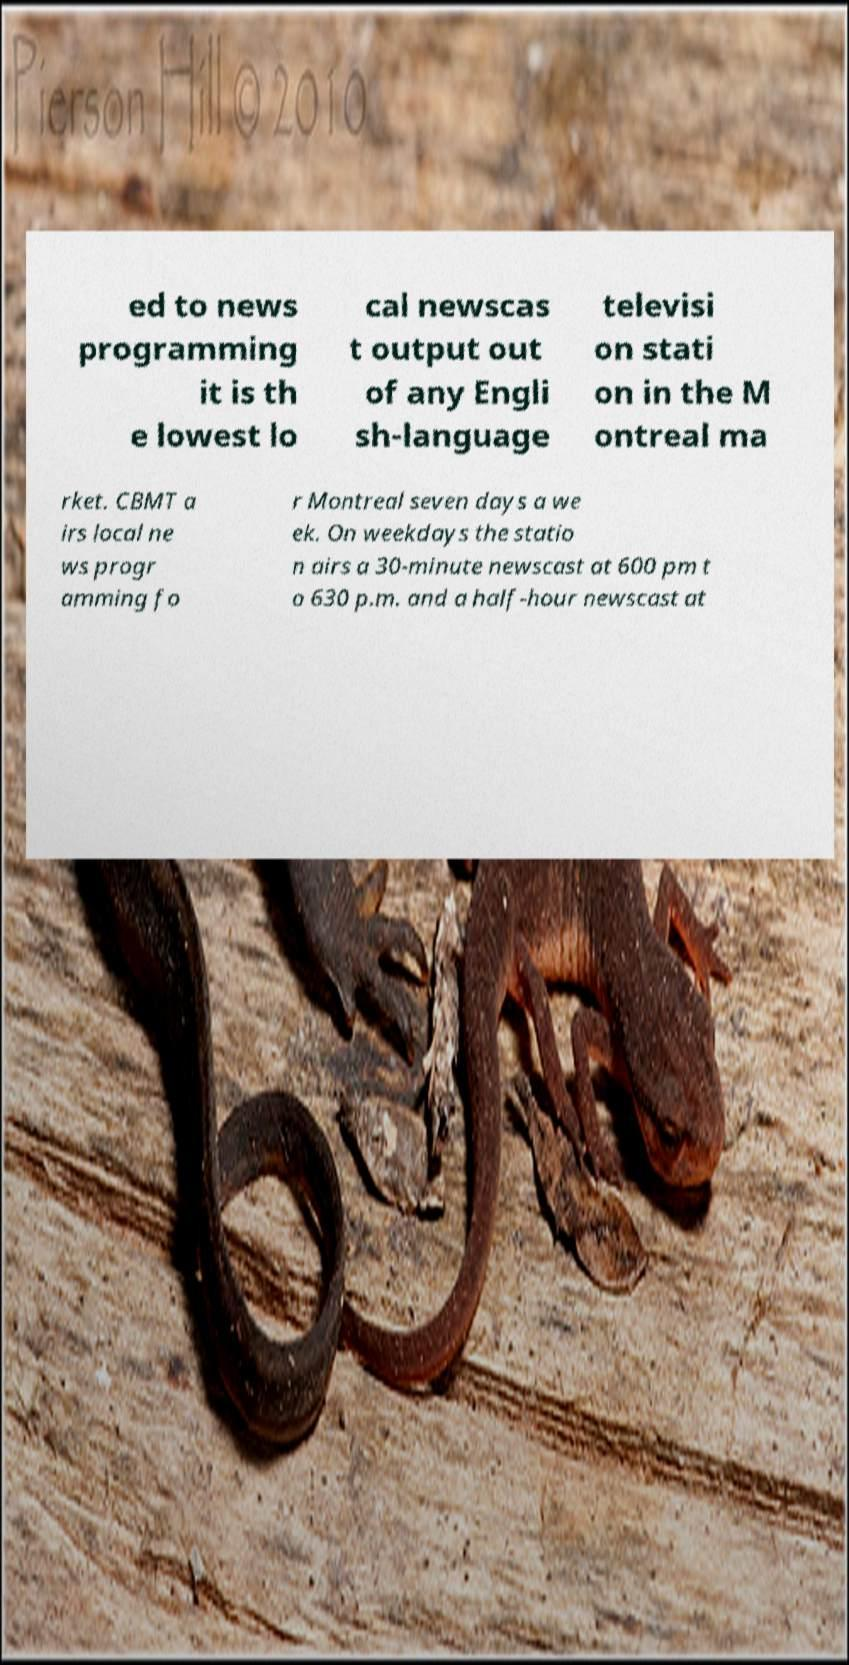Could you assist in decoding the text presented in this image and type it out clearly? ed to news programming it is th e lowest lo cal newscas t output out of any Engli sh-language televisi on stati on in the M ontreal ma rket. CBMT a irs local ne ws progr amming fo r Montreal seven days a we ek. On weekdays the statio n airs a 30-minute newscast at 600 pm t o 630 p.m. and a half-hour newscast at 